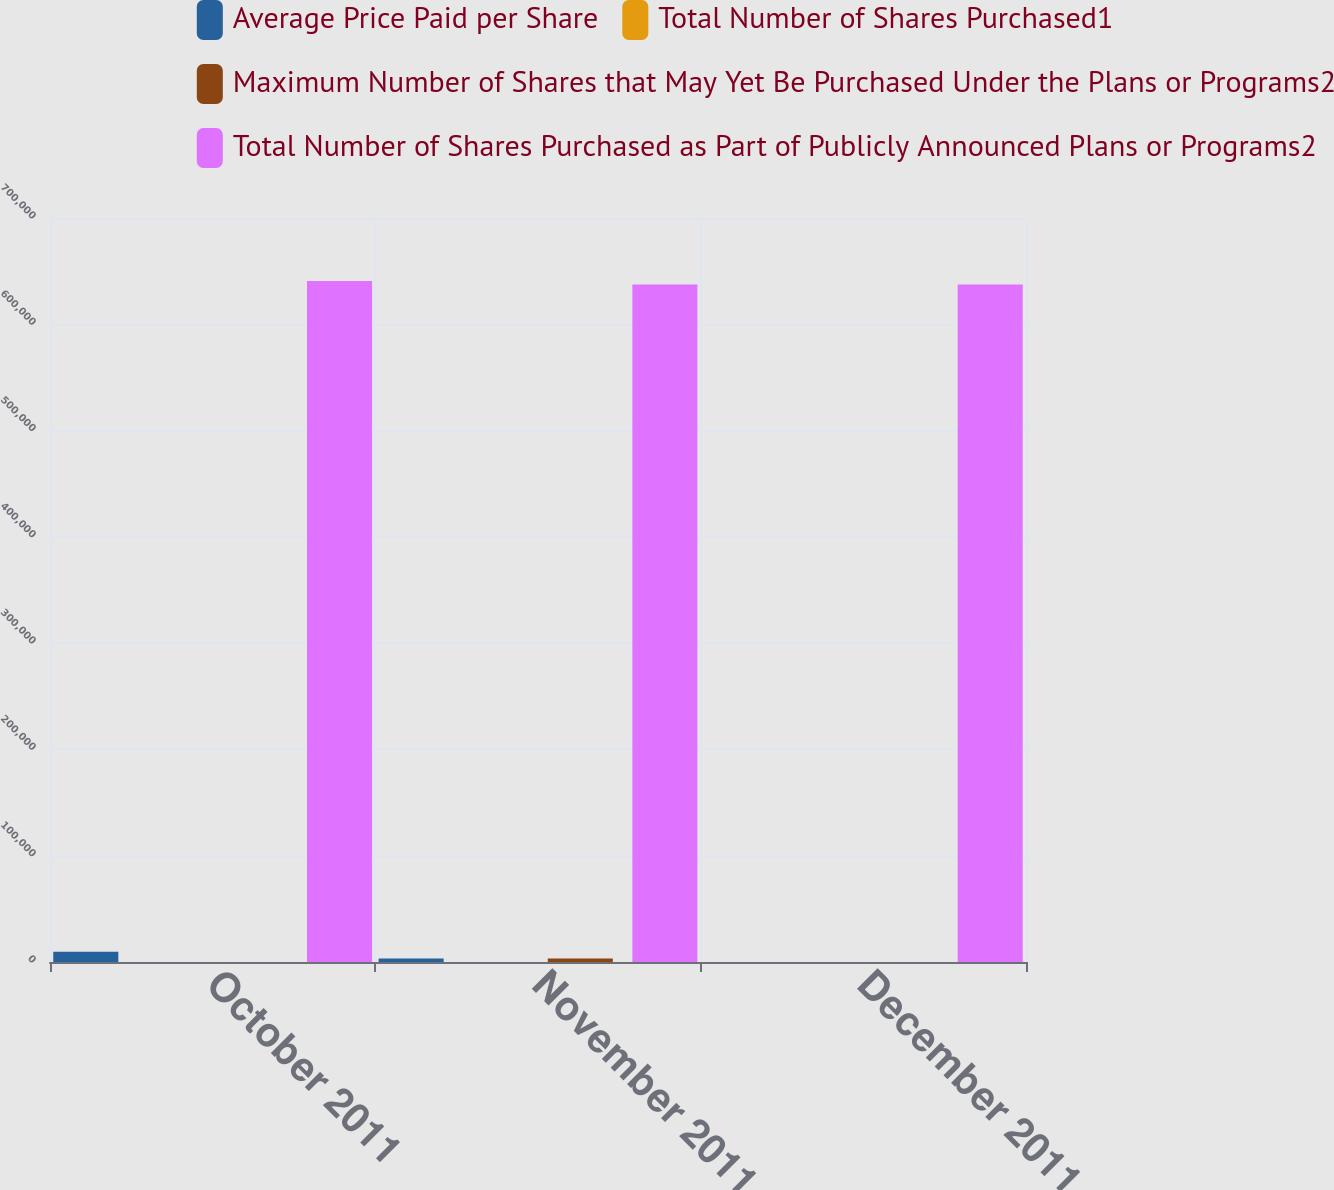Convert chart. <chart><loc_0><loc_0><loc_500><loc_500><stacked_bar_chart><ecel><fcel>October 2011<fcel>November 2011<fcel>December 2011<nl><fcel>Average Price Paid per Share<fcel>9740<fcel>3279<fcel>0<nl><fcel>Total Number of Shares Purchased1<fcel>23.18<fcel>21.9<fcel>0<nl><fcel>Maximum Number of Shares that May Yet Be Purchased Under the Plans or Programs2<fcel>0<fcel>3279<fcel>0<nl><fcel>Total Number of Shares Purchased as Part of Publicly Announced Plans or Programs2<fcel>640811<fcel>637532<fcel>637532<nl></chart> 